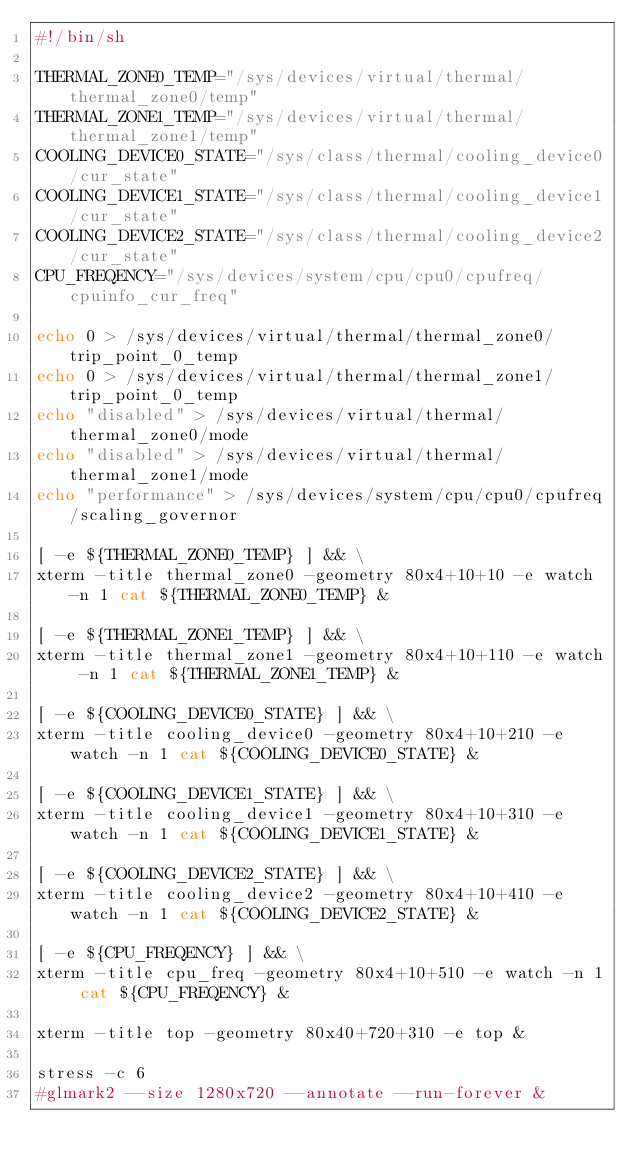<code> <loc_0><loc_0><loc_500><loc_500><_Bash_>#!/bin/sh

THERMAL_ZONE0_TEMP="/sys/devices/virtual/thermal/thermal_zone0/temp"
THERMAL_ZONE1_TEMP="/sys/devices/virtual/thermal/thermal_zone1/temp"
COOLING_DEVICE0_STATE="/sys/class/thermal/cooling_device0/cur_state"
COOLING_DEVICE1_STATE="/sys/class/thermal/cooling_device1/cur_state"
COOLING_DEVICE2_STATE="/sys/class/thermal/cooling_device2/cur_state"
CPU_FREQENCY="/sys/devices/system/cpu/cpu0/cpufreq/cpuinfo_cur_freq"

echo 0 > /sys/devices/virtual/thermal/thermal_zone0/trip_point_0_temp
echo 0 > /sys/devices/virtual/thermal/thermal_zone1/trip_point_0_temp
echo "disabled" > /sys/devices/virtual/thermal/thermal_zone0/mode
echo "disabled" > /sys/devices/virtual/thermal/thermal_zone1/mode
echo "performance" > /sys/devices/system/cpu/cpu0/cpufreq/scaling_governor

[ -e ${THERMAL_ZONE0_TEMP} ] && \
xterm -title thermal_zone0 -geometry 80x4+10+10 -e watch -n 1 cat ${THERMAL_ZONE0_TEMP} &

[ -e ${THERMAL_ZONE1_TEMP} ] && \
xterm -title thermal_zone1 -geometry 80x4+10+110 -e watch -n 1 cat ${THERMAL_ZONE1_TEMP} &

[ -e ${COOLING_DEVICE0_STATE} ] && \
xterm -title cooling_device0 -geometry 80x4+10+210 -e watch -n 1 cat ${COOLING_DEVICE0_STATE} &

[ -e ${COOLING_DEVICE1_STATE} ] && \
xterm -title cooling_device1 -geometry 80x4+10+310 -e watch -n 1 cat ${COOLING_DEVICE1_STATE} &

[ -e ${COOLING_DEVICE2_STATE} ] && \
xterm -title cooling_device2 -geometry 80x4+10+410 -e watch -n 1 cat ${COOLING_DEVICE2_STATE} &

[ -e ${CPU_FREQENCY} ] && \
xterm -title cpu_freq -geometry 80x4+10+510 -e watch -n 1 cat ${CPU_FREQENCY} &

xterm -title top -geometry 80x40+720+310 -e top &

stress -c 6
#glmark2 --size 1280x720 --annotate --run-forever &
</code> 